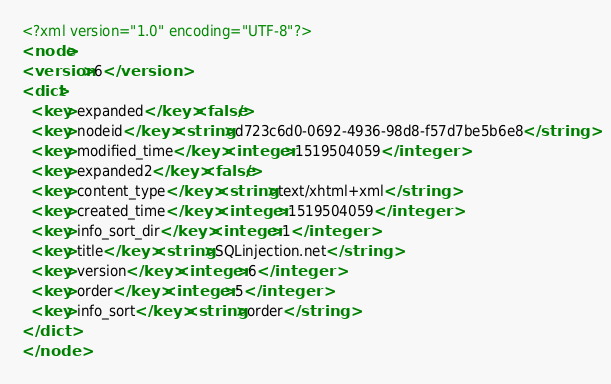<code> <loc_0><loc_0><loc_500><loc_500><_XML_><?xml version="1.0" encoding="UTF-8"?>
<node>
<version>6</version>
<dict>
  <key>expanded</key><false/>
  <key>nodeid</key><string>d723c6d0-0692-4936-98d8-f57d7be5b6e8</string>
  <key>modified_time</key><integer>1519504059</integer>
  <key>expanded2</key><false/>
  <key>content_type</key><string>text/xhtml+xml</string>
  <key>created_time</key><integer>1519504059</integer>
  <key>info_sort_dir</key><integer>1</integer>
  <key>title</key><string>SQLinjection.net</string>
  <key>version</key><integer>6</integer>
  <key>order</key><integer>5</integer>
  <key>info_sort</key><string>order</string>
</dict>
</node>
</code> 